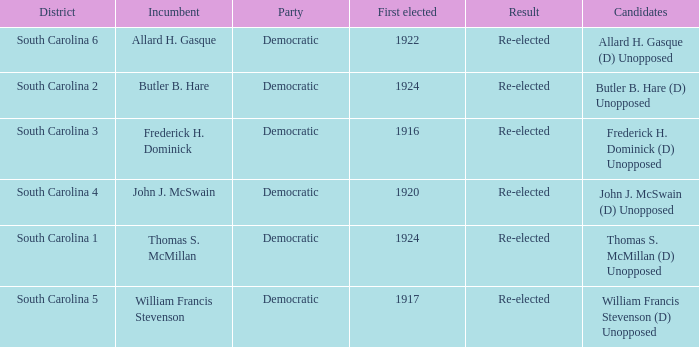What is the party for south carolina 3? Democratic. Parse the full table. {'header': ['District', 'Incumbent', 'Party', 'First elected', 'Result', 'Candidates'], 'rows': [['South Carolina 6', 'Allard H. Gasque', 'Democratic', '1922', 'Re-elected', 'Allard H. Gasque (D) Unopposed'], ['South Carolina 2', 'Butler B. Hare', 'Democratic', '1924', 'Re-elected', 'Butler B. Hare (D) Unopposed'], ['South Carolina 3', 'Frederick H. Dominick', 'Democratic', '1916', 'Re-elected', 'Frederick H. Dominick (D) Unopposed'], ['South Carolina 4', 'John J. McSwain', 'Democratic', '1920', 'Re-elected', 'John J. McSwain (D) Unopposed'], ['South Carolina 1', 'Thomas S. McMillan', 'Democratic', '1924', 'Re-elected', 'Thomas S. McMillan (D) Unopposed'], ['South Carolina 5', 'William Francis Stevenson', 'Democratic', '1917', 'Re-elected', 'William Francis Stevenson (D) Unopposed']]} 